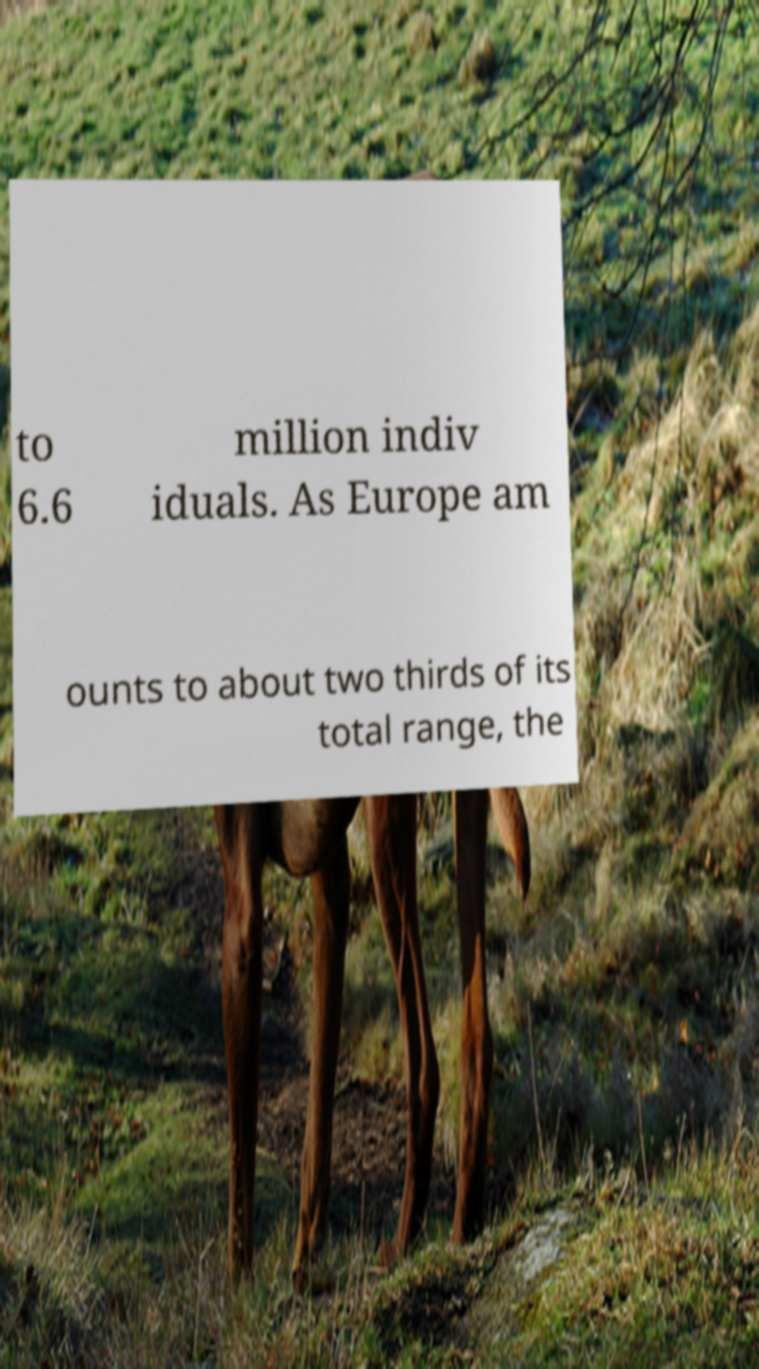For documentation purposes, I need the text within this image transcribed. Could you provide that? to 6.6 million indiv iduals. As Europe am ounts to about two thirds of its total range, the 